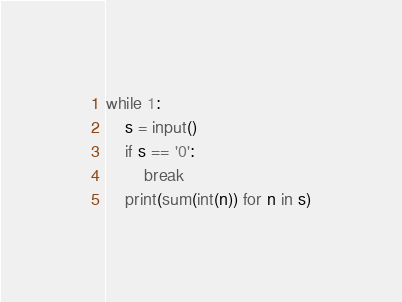Convert code to text. <code><loc_0><loc_0><loc_500><loc_500><_Python_>while 1:
    s = input()
    if s == '0':
        break
    print(sum(int(n)) for n in s)</code> 